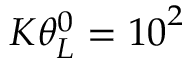Convert formula to latex. <formula><loc_0><loc_0><loc_500><loc_500>K \theta _ { L } ^ { 0 } = { { 1 0 } ^ { 2 } }</formula> 